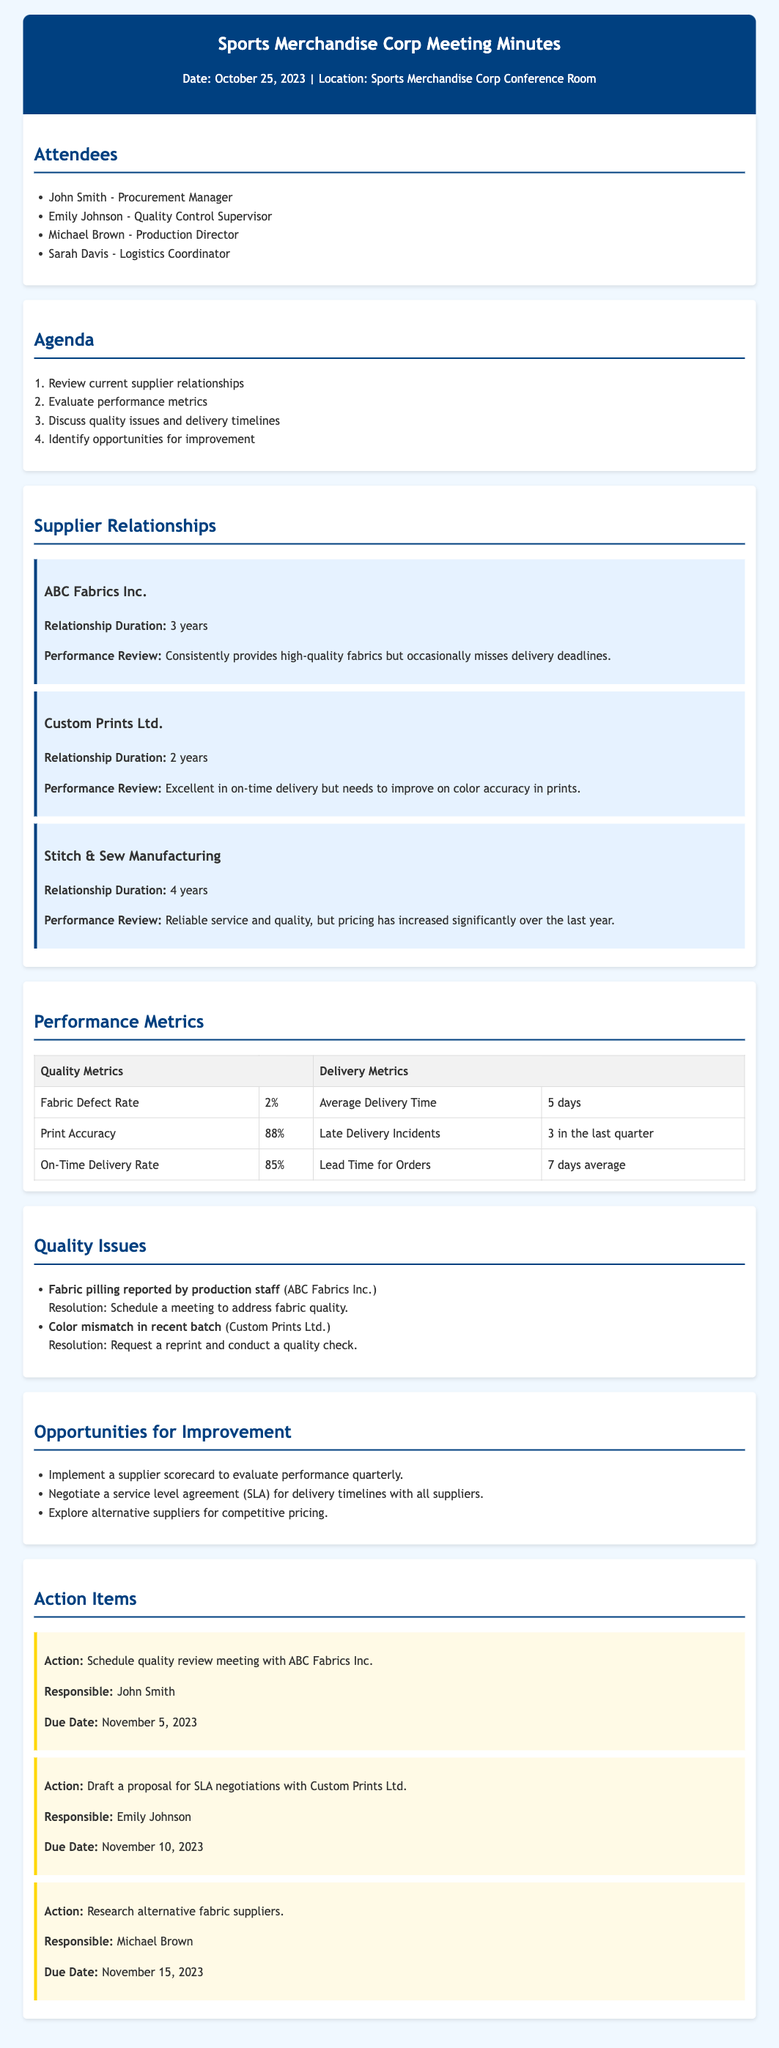What is the date of the meeting? The meeting date is mentioned in the header section of the document.
Answer: October 25, 2023 Who is responsible for the action item regarding the quality review meeting with ABC Fabrics Inc.? The responsible person for the action item can be found in the action items section of the document.
Answer: John Smith What is the average delivery time reported in the performance metrics? The average delivery time is listed in the performance metrics table.
Answer: 5 days What quality issue was reported by the production staff? A specific quality issue is highlighted under the quality issues section.
Answer: Fabric pilling How long has Custom Prints Ltd. been a supplier? The relationship duration is noted in the supplier relationships section.
Answer: 2 years What is the on-time delivery rate mentioned in the performance metrics? The on-time delivery rate is outlined in the performance metrics table.
Answer: 85% What action item is due on November 10, 2023? The due date and associated action item are found in the action items section of the document.
Answer: Draft a proposal for SLA negotiations with Custom Prints Ltd What opportunity for improvement involves a supplier scorecard? The opportunities for improvement section lists multiple opportunities, one of which mentions a supplier scorecard.
Answer: Implement a supplier scorecard to evaluate performance quarterly What is the color accuracy percentage reported in print accuracy? The percentage for print accuracy is listed in the performance metrics table.
Answer: 88% 